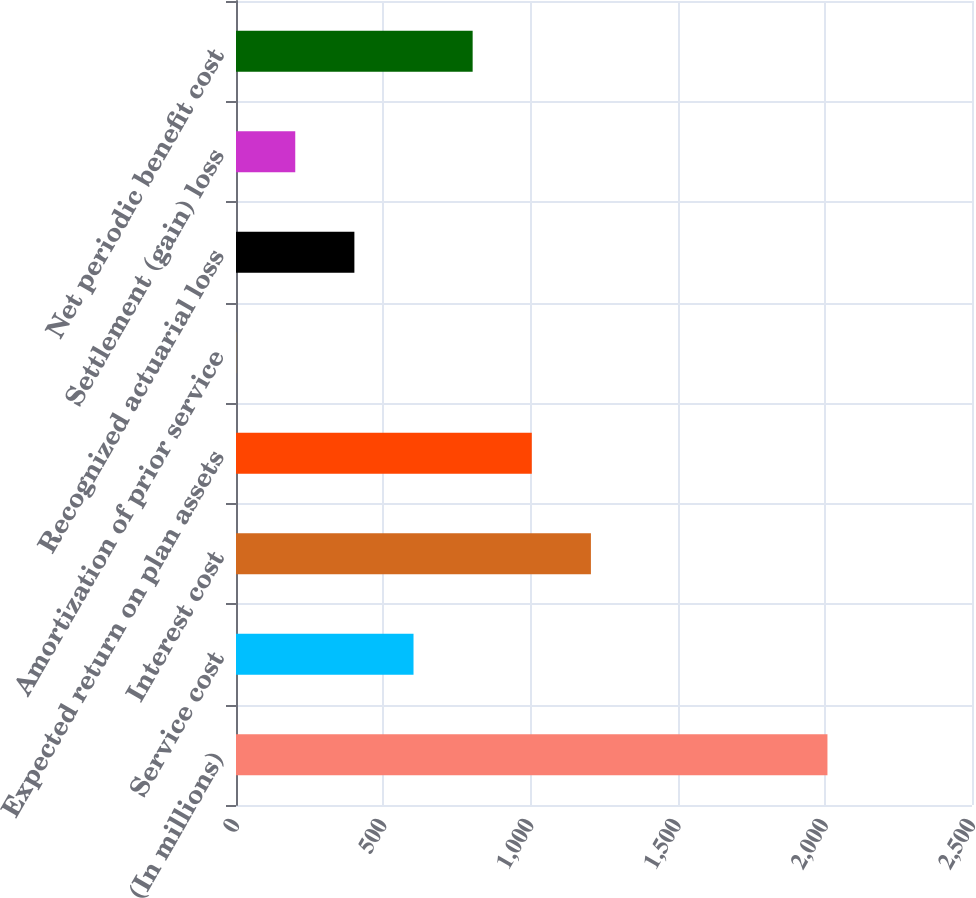Convert chart to OTSL. <chart><loc_0><loc_0><loc_500><loc_500><bar_chart><fcel>(In millions)<fcel>Service cost<fcel>Interest cost<fcel>Expected return on plan assets<fcel>Amortization of prior service<fcel>Recognized actuarial loss<fcel>Settlement (gain) loss<fcel>Net periodic benefit cost<nl><fcel>2009<fcel>602.98<fcel>1205.56<fcel>1004.7<fcel>0.4<fcel>402.12<fcel>201.26<fcel>803.84<nl></chart> 